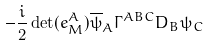Convert formula to latex. <formula><loc_0><loc_0><loc_500><loc_500>- \frac { i } { 2 } \det ( e _ { M } ^ { A } ) \overline { \psi } _ { A } \Gamma ^ { A B C } D _ { B } \psi _ { C }</formula> 